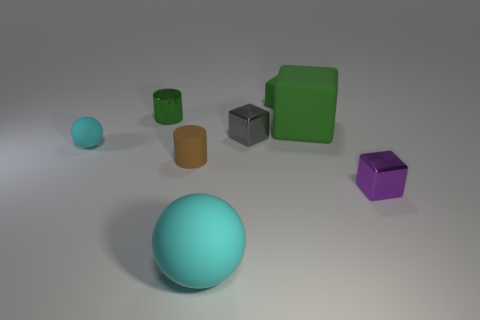Subtract all purple metal blocks. How many blocks are left? 3 Add 1 yellow matte objects. How many objects exist? 9 Subtract 4 cubes. How many cubes are left? 0 Subtract all green spheres. How many green blocks are left? 2 Subtract all balls. How many objects are left? 6 Add 6 large red rubber balls. How many large red rubber balls exist? 6 Subtract all purple cubes. How many cubes are left? 3 Subtract 1 green blocks. How many objects are left? 7 Subtract all cyan blocks. Subtract all green cylinders. How many blocks are left? 4 Subtract all matte cylinders. Subtract all big green objects. How many objects are left? 6 